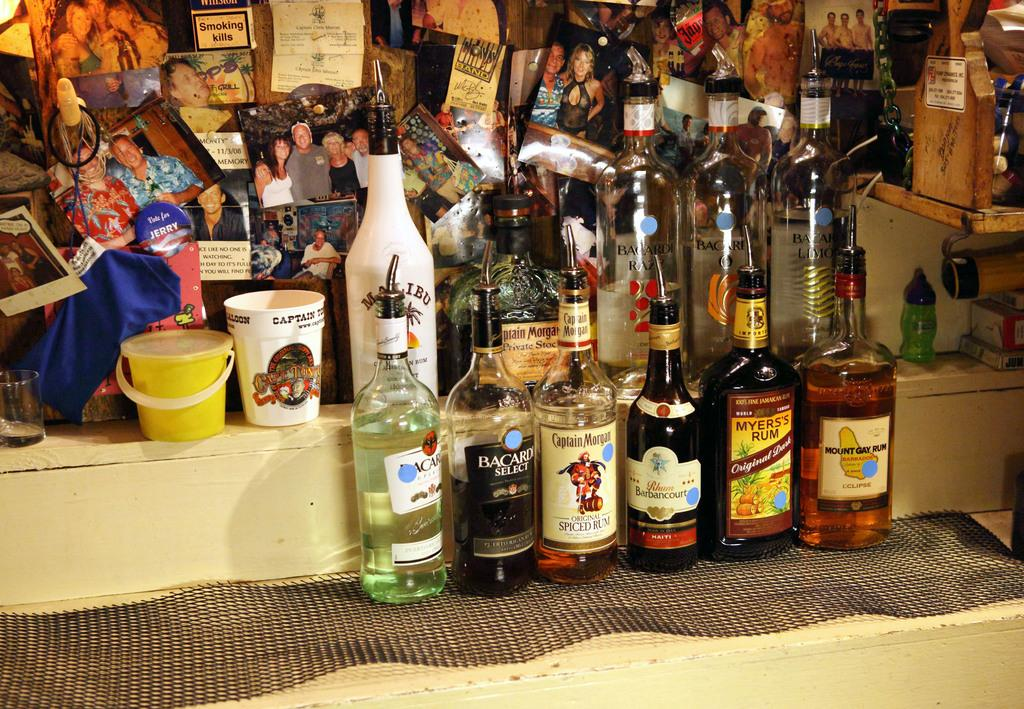<image>
Summarize the visual content of the image. bottles of liquor line like Myers's Rum and Mount Gay rum line a table 